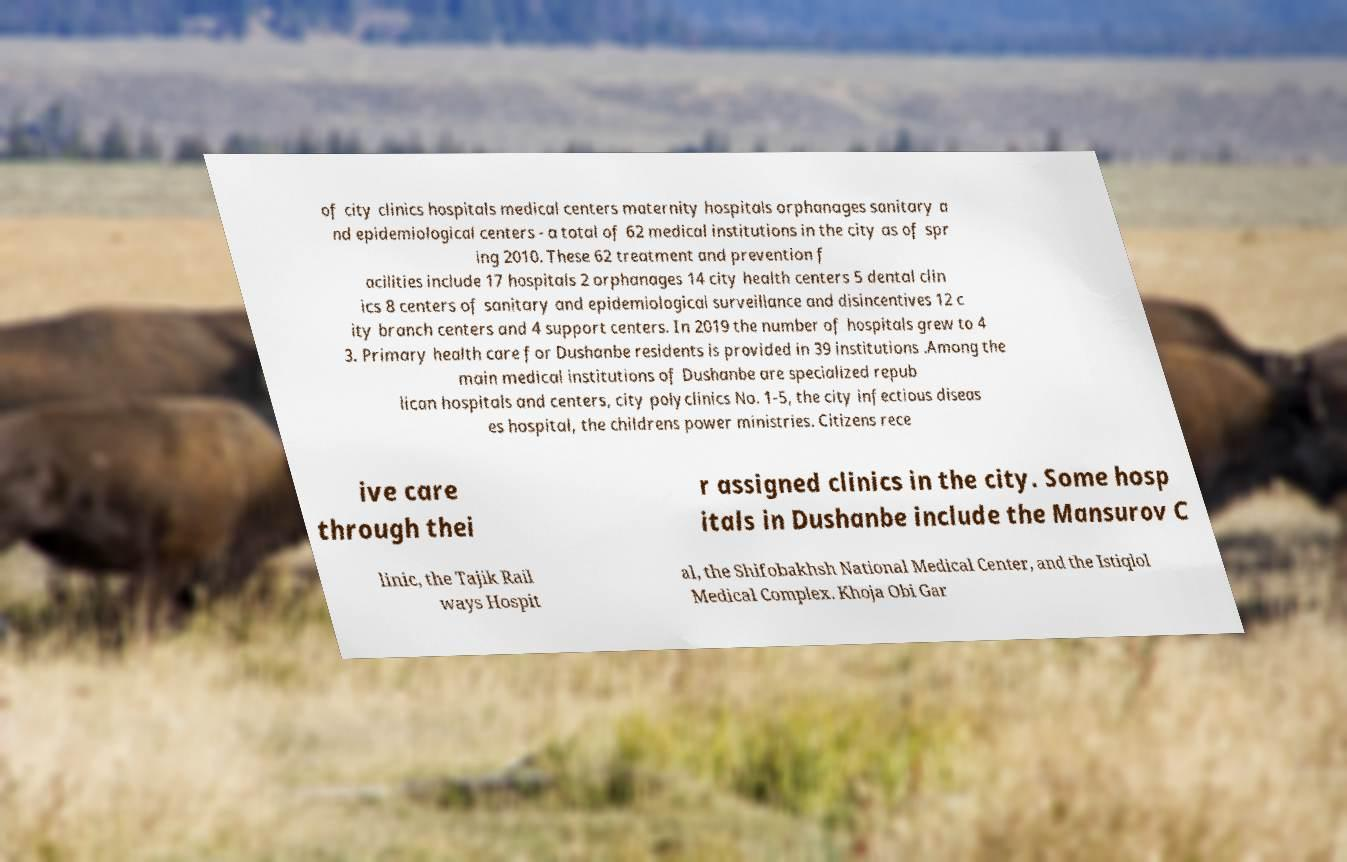There's text embedded in this image that I need extracted. Can you transcribe it verbatim? of city clinics hospitals medical centers maternity hospitals orphanages sanitary a nd epidemiological centers - a total of 62 medical institutions in the city as of spr ing 2010. These 62 treatment and prevention f acilities include 17 hospitals 2 orphanages 14 city health centers 5 dental clin ics 8 centers of sanitary and epidemiological surveillance and disincentives 12 c ity branch centers and 4 support centers. In 2019 the number of hospitals grew to 4 3. Primary health care for Dushanbe residents is provided in 39 institutions .Among the main medical institutions of Dushanbe are specialized repub lican hospitals and centers, city polyclinics No. 1-5, the city infectious diseas es hospital, the childrens power ministries. Citizens rece ive care through thei r assigned clinics in the city. Some hosp itals in Dushanbe include the Mansurov C linic, the Tajik Rail ways Hospit al, the Shifobakhsh National Medical Center, and the Istiqlol Medical Complex. Khoja Obi Gar 